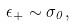<formula> <loc_0><loc_0><loc_500><loc_500>\epsilon _ { + } \sim \sigma _ { 0 } ,</formula> 